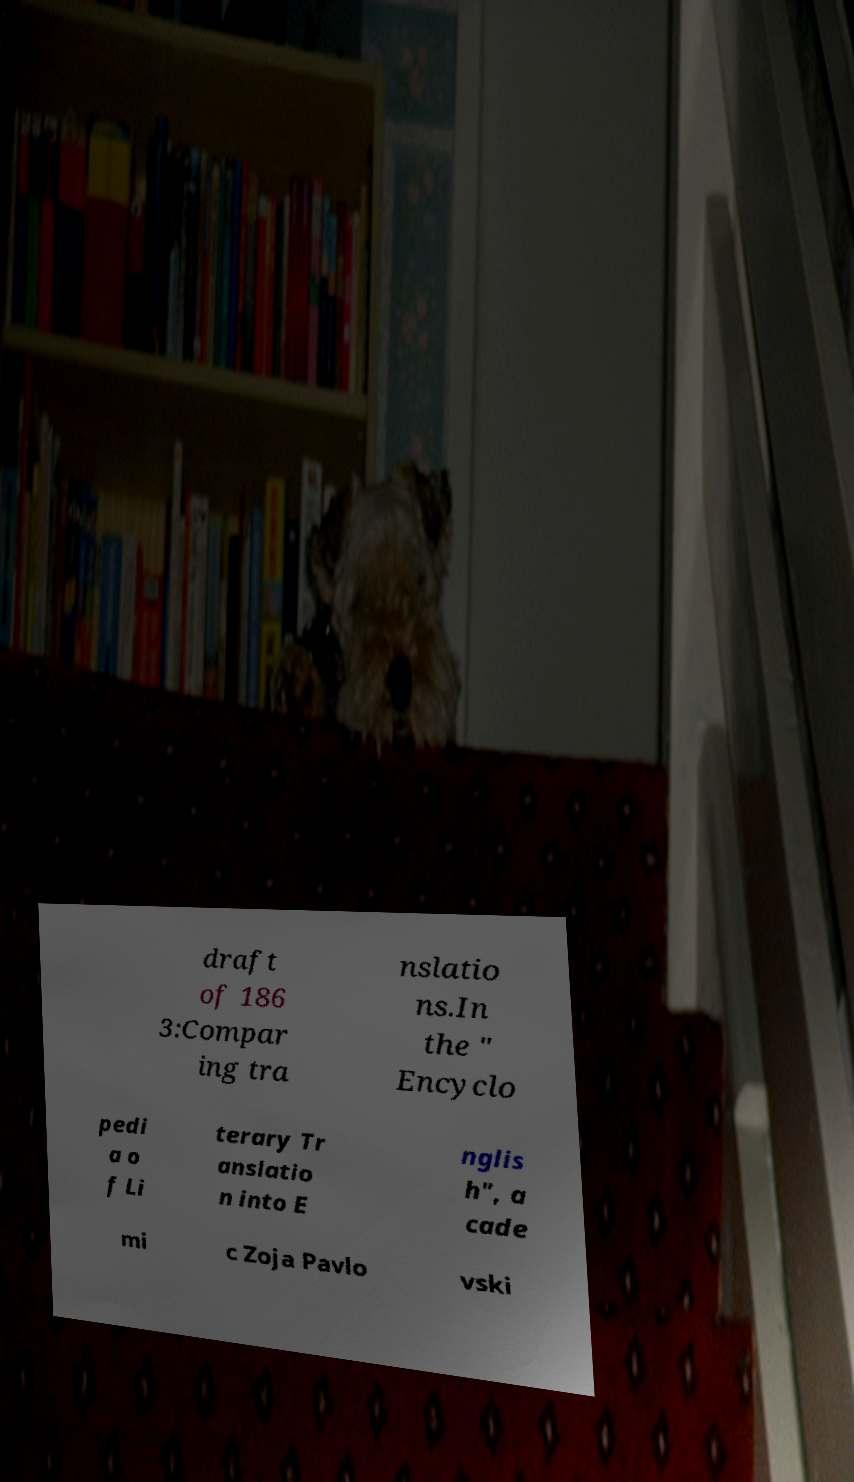Please read and relay the text visible in this image. What does it say? draft of 186 3:Compar ing tra nslatio ns.In the " Encyclo pedi a o f Li terary Tr anslatio n into E nglis h", a cade mi c Zoja Pavlo vski 